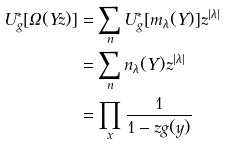Convert formula to latex. <formula><loc_0><loc_0><loc_500><loc_500>U ^ { * } _ { g } [ \Omega ( Y z ) ] & = \sum _ { n } U ^ { * } _ { g } [ m _ { \lambda } ( Y ) ] z ^ { | \lambda | } \\ & = \sum _ { n } n _ { \lambda } ( Y ) z ^ { | \lambda | } \\ & = \prod _ { x } \frac { 1 } { 1 - z g ( y ) }</formula> 